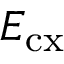Convert formula to latex. <formula><loc_0><loc_0><loc_500><loc_500>E _ { c x }</formula> 